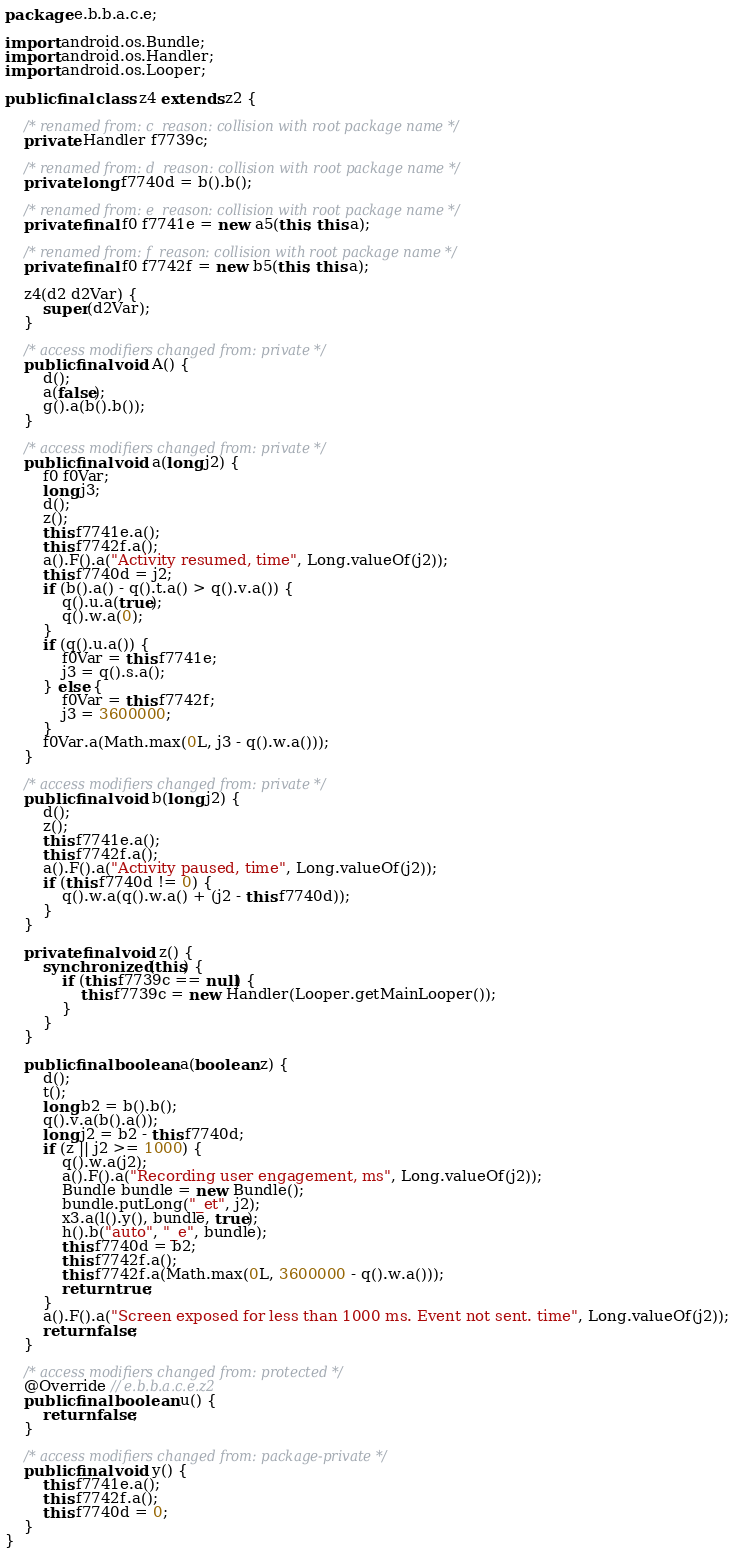<code> <loc_0><loc_0><loc_500><loc_500><_Java_>package e.b.b.a.c.e;

import android.os.Bundle;
import android.os.Handler;
import android.os.Looper;

public final class z4 extends z2 {

    /* renamed from: c  reason: collision with root package name */
    private Handler f7739c;

    /* renamed from: d  reason: collision with root package name */
    private long f7740d = b().b();

    /* renamed from: e  reason: collision with root package name */
    private final f0 f7741e = new a5(this, this.a);

    /* renamed from: f  reason: collision with root package name */
    private final f0 f7742f = new b5(this, this.a);

    z4(d2 d2Var) {
        super(d2Var);
    }

    /* access modifiers changed from: private */
    public final void A() {
        d();
        a(false);
        g().a(b().b());
    }

    /* access modifiers changed from: private */
    public final void a(long j2) {
        f0 f0Var;
        long j3;
        d();
        z();
        this.f7741e.a();
        this.f7742f.a();
        a().F().a("Activity resumed, time", Long.valueOf(j2));
        this.f7740d = j2;
        if (b().a() - q().t.a() > q().v.a()) {
            q().u.a(true);
            q().w.a(0);
        }
        if (q().u.a()) {
            f0Var = this.f7741e;
            j3 = q().s.a();
        } else {
            f0Var = this.f7742f;
            j3 = 3600000;
        }
        f0Var.a(Math.max(0L, j3 - q().w.a()));
    }

    /* access modifiers changed from: private */
    public final void b(long j2) {
        d();
        z();
        this.f7741e.a();
        this.f7742f.a();
        a().F().a("Activity paused, time", Long.valueOf(j2));
        if (this.f7740d != 0) {
            q().w.a(q().w.a() + (j2 - this.f7740d));
        }
    }

    private final void z() {
        synchronized (this) {
            if (this.f7739c == null) {
                this.f7739c = new Handler(Looper.getMainLooper());
            }
        }
    }

    public final boolean a(boolean z) {
        d();
        t();
        long b2 = b().b();
        q().v.a(b().a());
        long j2 = b2 - this.f7740d;
        if (z || j2 >= 1000) {
            q().w.a(j2);
            a().F().a("Recording user engagement, ms", Long.valueOf(j2));
            Bundle bundle = new Bundle();
            bundle.putLong("_et", j2);
            x3.a(l().y(), bundle, true);
            h().b("auto", "_e", bundle);
            this.f7740d = b2;
            this.f7742f.a();
            this.f7742f.a(Math.max(0L, 3600000 - q().w.a()));
            return true;
        }
        a().F().a("Screen exposed for less than 1000 ms. Event not sent. time", Long.valueOf(j2));
        return false;
    }

    /* access modifiers changed from: protected */
    @Override // e.b.b.a.c.e.z2
    public final boolean u() {
        return false;
    }

    /* access modifiers changed from: package-private */
    public final void y() {
        this.f7741e.a();
        this.f7742f.a();
        this.f7740d = 0;
    }
}
</code> 